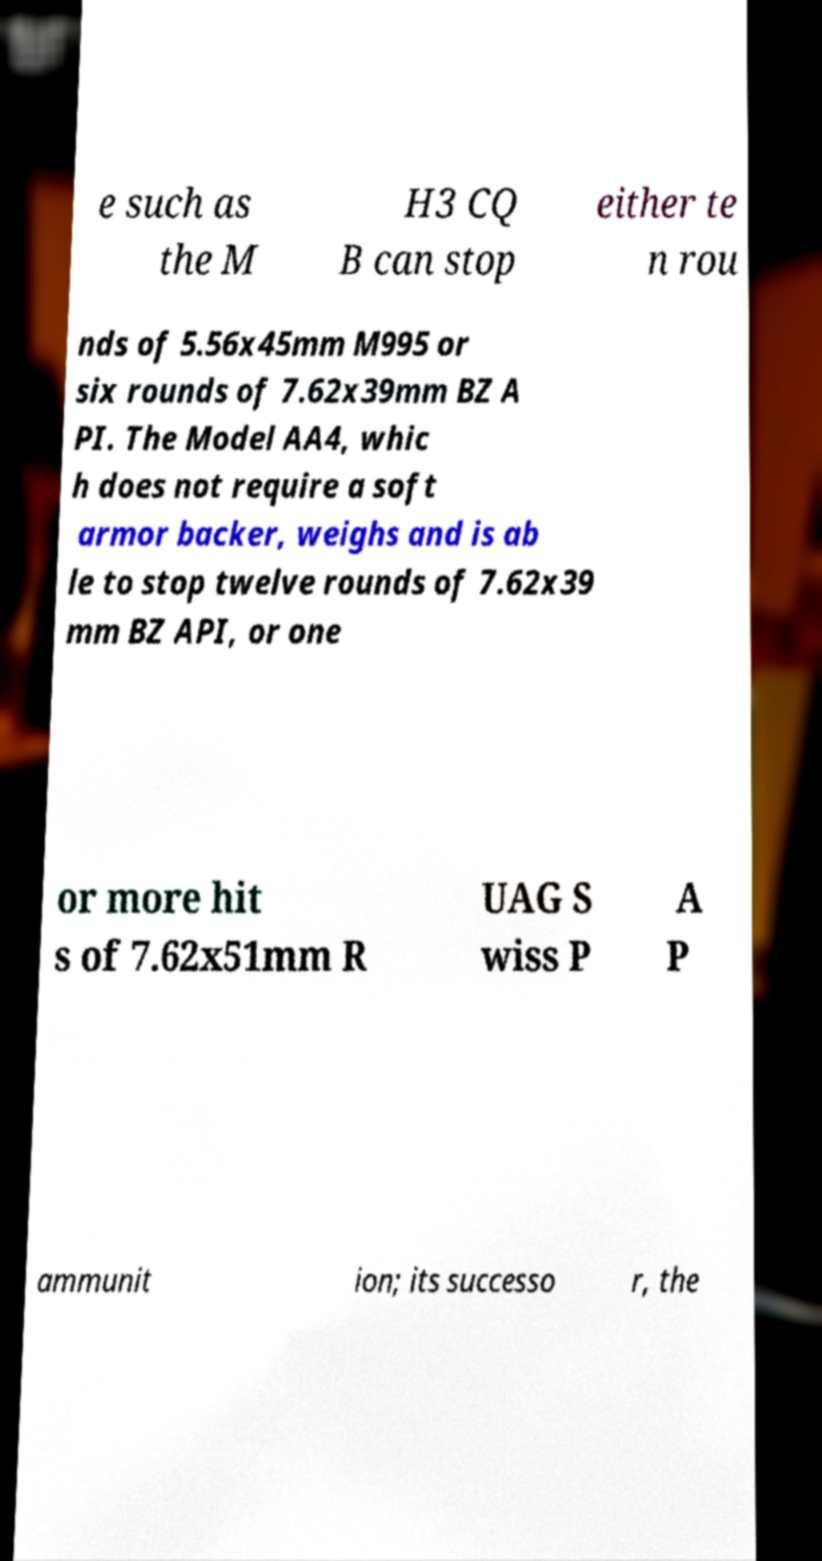Please identify and transcribe the text found in this image. e such as the M H3 CQ B can stop either te n rou nds of 5.56x45mm M995 or six rounds of 7.62x39mm BZ A PI. The Model AA4, whic h does not require a soft armor backer, weighs and is ab le to stop twelve rounds of 7.62x39 mm BZ API, or one or more hit s of 7.62x51mm R UAG S wiss P A P ammunit ion; its successo r, the 